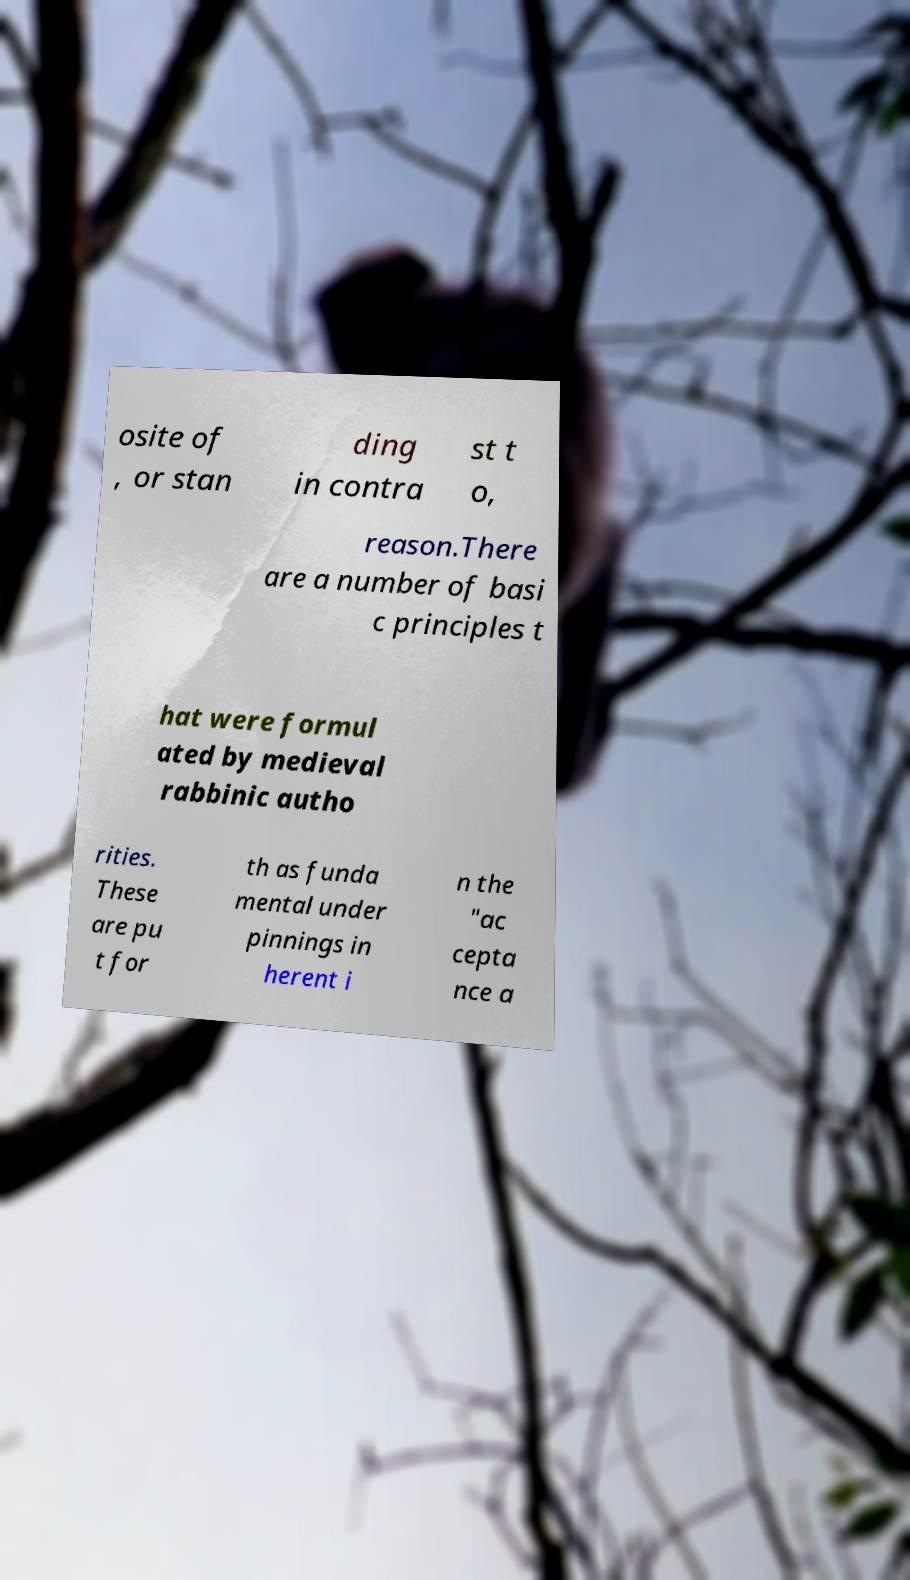Can you read and provide the text displayed in the image?This photo seems to have some interesting text. Can you extract and type it out for me? osite of , or stan ding in contra st t o, reason.There are a number of basi c principles t hat were formul ated by medieval rabbinic autho rities. These are pu t for th as funda mental under pinnings in herent i n the "ac cepta nce a 